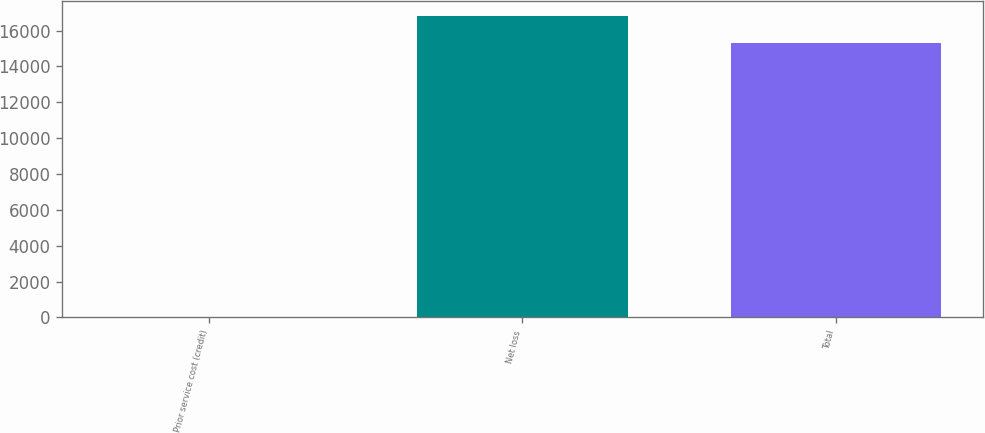<chart> <loc_0><loc_0><loc_500><loc_500><bar_chart><fcel>Prior service cost (credit)<fcel>Net loss<fcel>Total<nl><fcel>38<fcel>16821.2<fcel>15292<nl></chart> 